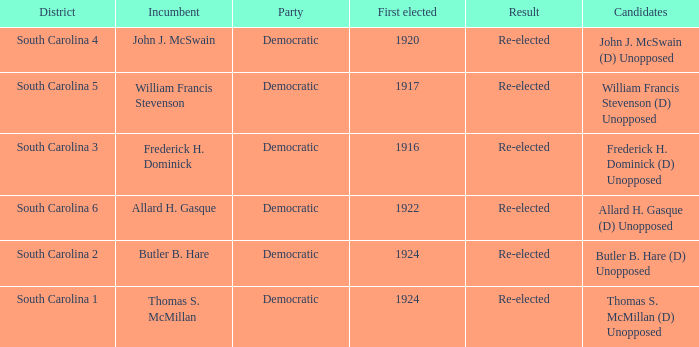Could you help me parse every detail presented in this table? {'header': ['District', 'Incumbent', 'Party', 'First elected', 'Result', 'Candidates'], 'rows': [['South Carolina 4', 'John J. McSwain', 'Democratic', '1920', 'Re-elected', 'John J. McSwain (D) Unopposed'], ['South Carolina 5', 'William Francis Stevenson', 'Democratic', '1917', 'Re-elected', 'William Francis Stevenson (D) Unopposed'], ['South Carolina 3', 'Frederick H. Dominick', 'Democratic', '1916', 'Re-elected', 'Frederick H. Dominick (D) Unopposed'], ['South Carolina 6', 'Allard H. Gasque', 'Democratic', '1922', 'Re-elected', 'Allard H. Gasque (D) Unopposed'], ['South Carolina 2', 'Butler B. Hare', 'Democratic', '1924', 'Re-elected', 'Butler B. Hare (D) Unopposed'], ['South Carolina 1', 'Thomas S. McMillan', 'Democratic', '1924', 'Re-elected', 'Thomas S. McMillan (D) Unopposed']]} Name the candidate for south carolina 1? Thomas S. McMillan (D) Unopposed. 